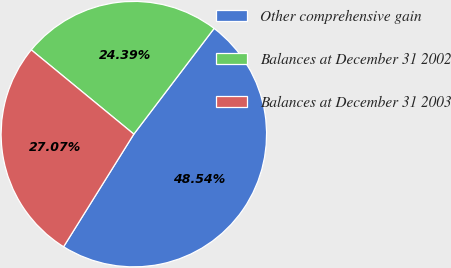Convert chart to OTSL. <chart><loc_0><loc_0><loc_500><loc_500><pie_chart><fcel>Other comprehensive gain<fcel>Balances at December 31 2002<fcel>Balances at December 31 2003<nl><fcel>48.54%<fcel>24.39%<fcel>27.07%<nl></chart> 